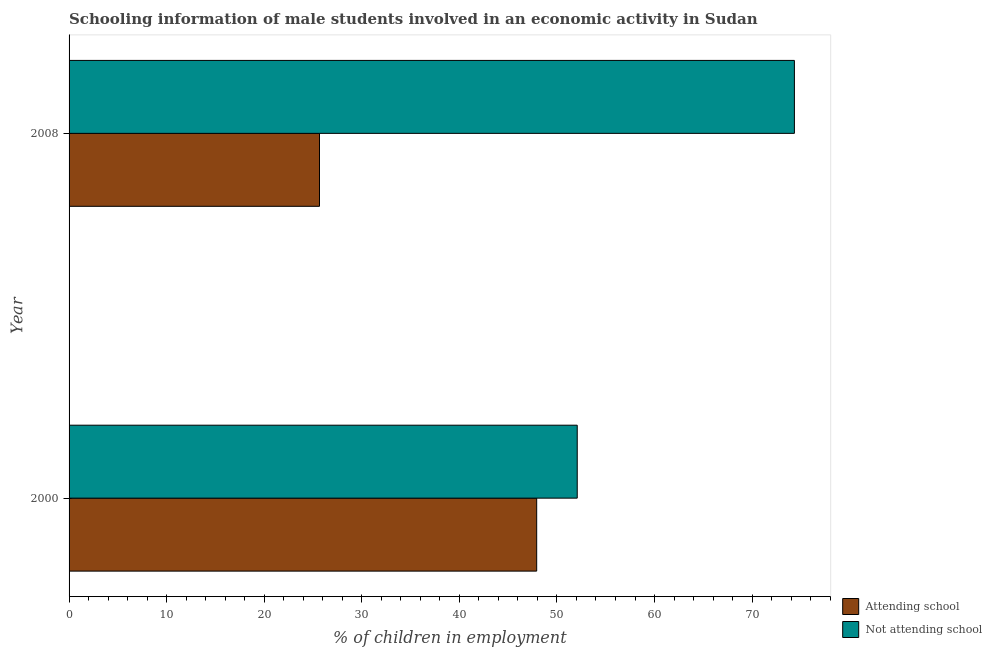How many different coloured bars are there?
Offer a terse response. 2. How many bars are there on the 2nd tick from the top?
Give a very brief answer. 2. How many bars are there on the 2nd tick from the bottom?
Offer a very short reply. 2. What is the label of the 2nd group of bars from the top?
Your response must be concise. 2000. What is the percentage of employed males who are not attending school in 2008?
Offer a terse response. 74.33. Across all years, what is the maximum percentage of employed males who are not attending school?
Your answer should be compact. 74.33. Across all years, what is the minimum percentage of employed males who are attending school?
Offer a very short reply. 25.67. In which year was the percentage of employed males who are not attending school minimum?
Provide a short and direct response. 2000. What is the total percentage of employed males who are not attending school in the graph?
Offer a very short reply. 126.41. What is the difference between the percentage of employed males who are attending school in 2000 and that in 2008?
Give a very brief answer. 22.26. What is the difference between the percentage of employed males who are not attending school in 2000 and the percentage of employed males who are attending school in 2008?
Make the answer very short. 26.41. What is the average percentage of employed males who are attending school per year?
Your answer should be very brief. 36.79. In the year 2000, what is the difference between the percentage of employed males who are attending school and percentage of employed males who are not attending school?
Your response must be concise. -4.16. What is the ratio of the percentage of employed males who are attending school in 2000 to that in 2008?
Make the answer very short. 1.87. What does the 1st bar from the top in 2008 represents?
Keep it short and to the point. Not attending school. What does the 2nd bar from the bottom in 2000 represents?
Offer a terse response. Not attending school. How many bars are there?
Provide a succinct answer. 4. Are all the bars in the graph horizontal?
Your response must be concise. Yes. How many years are there in the graph?
Provide a succinct answer. 2. Are the values on the major ticks of X-axis written in scientific E-notation?
Ensure brevity in your answer.  No. What is the title of the graph?
Provide a succinct answer. Schooling information of male students involved in an economic activity in Sudan. What is the label or title of the X-axis?
Keep it short and to the point. % of children in employment. What is the label or title of the Y-axis?
Your response must be concise. Year. What is the % of children in employment of Attending school in 2000?
Offer a very short reply. 47.92. What is the % of children in employment in Not attending school in 2000?
Make the answer very short. 52.08. What is the % of children in employment of Attending school in 2008?
Ensure brevity in your answer.  25.67. What is the % of children in employment of Not attending school in 2008?
Ensure brevity in your answer.  74.33. Across all years, what is the maximum % of children in employment in Attending school?
Ensure brevity in your answer.  47.92. Across all years, what is the maximum % of children in employment in Not attending school?
Provide a succinct answer. 74.33. Across all years, what is the minimum % of children in employment in Attending school?
Offer a very short reply. 25.67. Across all years, what is the minimum % of children in employment of Not attending school?
Your response must be concise. 52.08. What is the total % of children in employment in Attending school in the graph?
Ensure brevity in your answer.  73.59. What is the total % of children in employment in Not attending school in the graph?
Provide a succinct answer. 126.41. What is the difference between the % of children in employment of Attending school in 2000 and that in 2008?
Give a very brief answer. 22.26. What is the difference between the % of children in employment in Not attending school in 2000 and that in 2008?
Ensure brevity in your answer.  -22.26. What is the difference between the % of children in employment in Attending school in 2000 and the % of children in employment in Not attending school in 2008?
Offer a very short reply. -26.41. What is the average % of children in employment of Attending school per year?
Provide a succinct answer. 36.79. What is the average % of children in employment of Not attending school per year?
Your response must be concise. 63.21. In the year 2000, what is the difference between the % of children in employment in Attending school and % of children in employment in Not attending school?
Keep it short and to the point. -4.16. In the year 2008, what is the difference between the % of children in employment in Attending school and % of children in employment in Not attending school?
Make the answer very short. -48.67. What is the ratio of the % of children in employment of Attending school in 2000 to that in 2008?
Make the answer very short. 1.87. What is the ratio of the % of children in employment in Not attending school in 2000 to that in 2008?
Your response must be concise. 0.7. What is the difference between the highest and the second highest % of children in employment in Attending school?
Offer a terse response. 22.26. What is the difference between the highest and the second highest % of children in employment in Not attending school?
Provide a short and direct response. 22.26. What is the difference between the highest and the lowest % of children in employment of Attending school?
Keep it short and to the point. 22.26. What is the difference between the highest and the lowest % of children in employment in Not attending school?
Offer a very short reply. 22.26. 